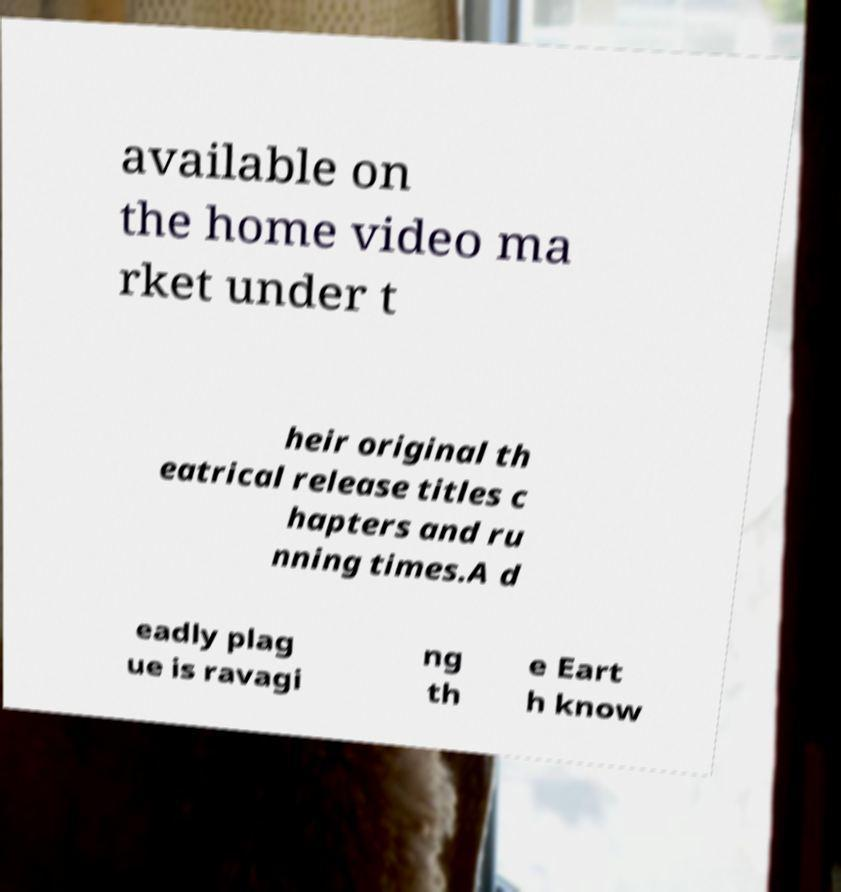For documentation purposes, I need the text within this image transcribed. Could you provide that? available on the home video ma rket under t heir original th eatrical release titles c hapters and ru nning times.A d eadly plag ue is ravagi ng th e Eart h know 